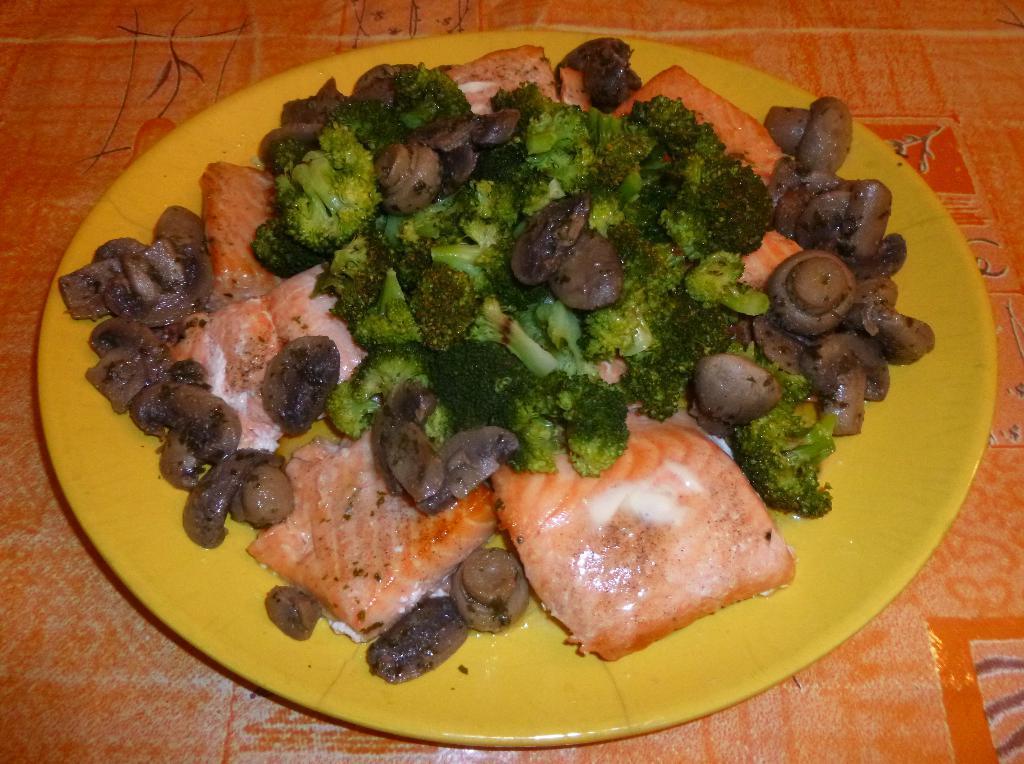How would you summarize this image in a sentence or two? This image consists of a food kept in a plate. The plate is in yellow color. At the bottom, it looks like a table. 